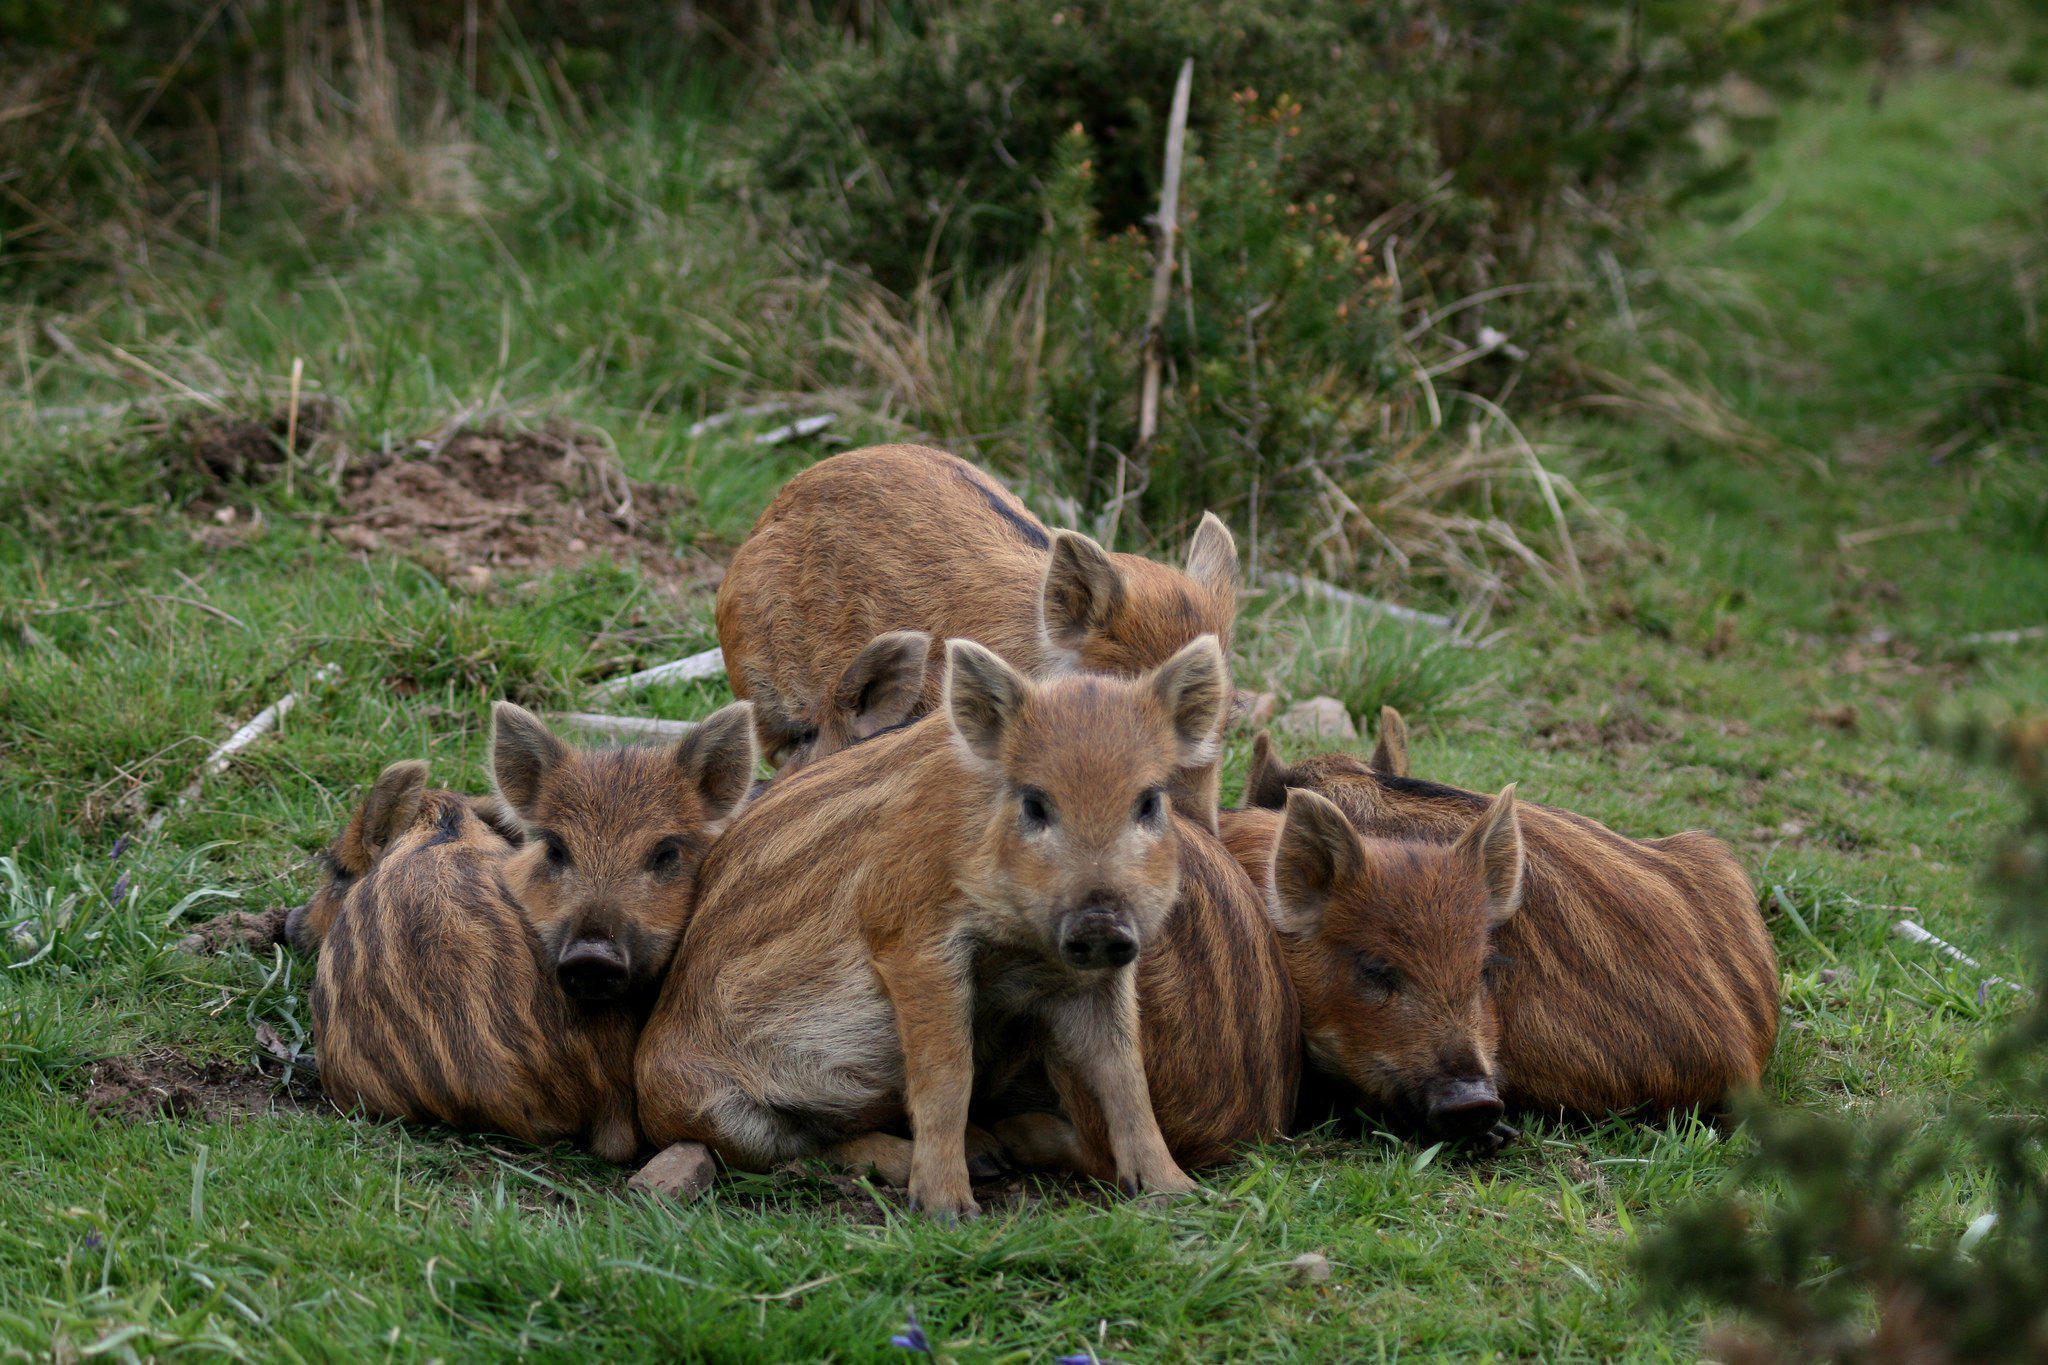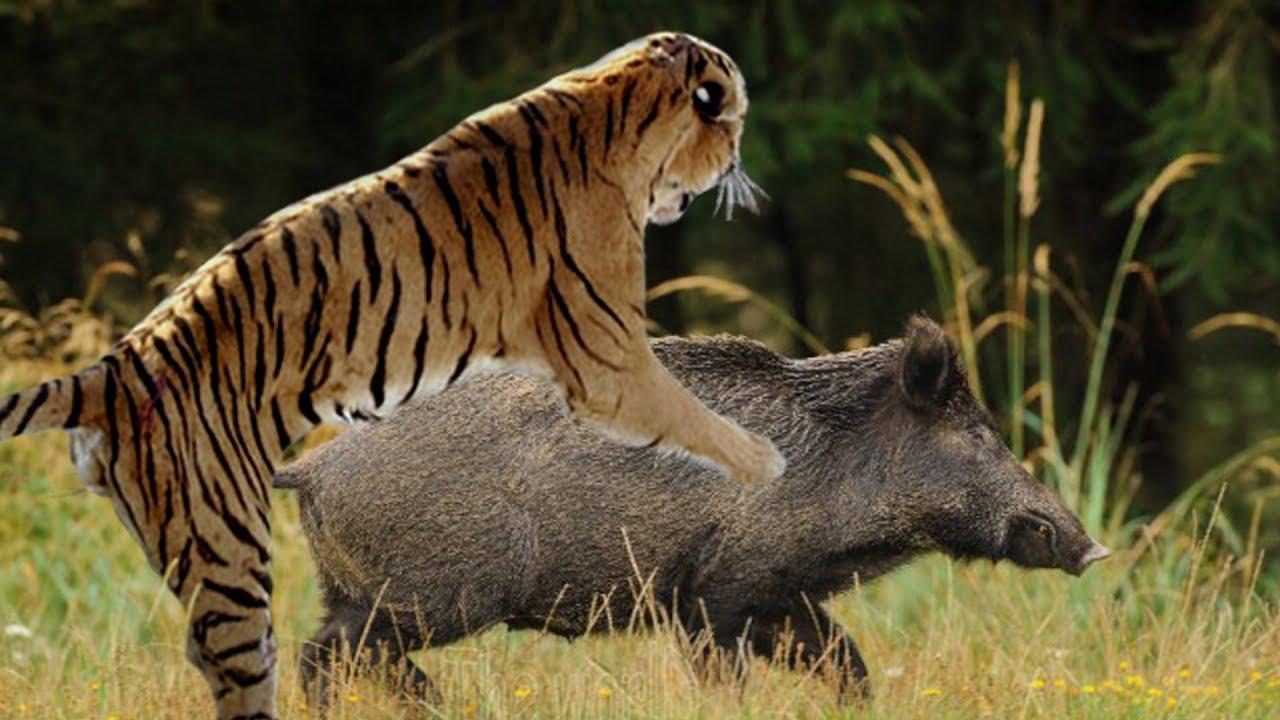The first image is the image on the left, the second image is the image on the right. Examine the images to the left and right. Is the description "There is a tiger attacking a boar." accurate? Answer yes or no. Yes. The first image is the image on the left, the second image is the image on the right. Examine the images to the left and right. Is the description "In one of the image there is a tiger attacking a pig." accurate? Answer yes or no. Yes. 